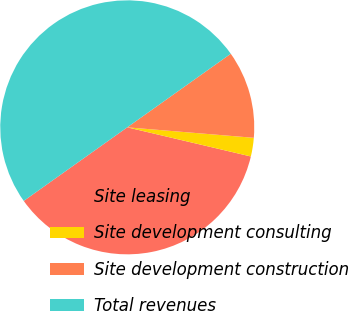Convert chart. <chart><loc_0><loc_0><loc_500><loc_500><pie_chart><fcel>Site leasing<fcel>Site development consulting<fcel>Site development construction<fcel>Total revenues<nl><fcel>36.48%<fcel>2.37%<fcel>11.15%<fcel>50.0%<nl></chart> 